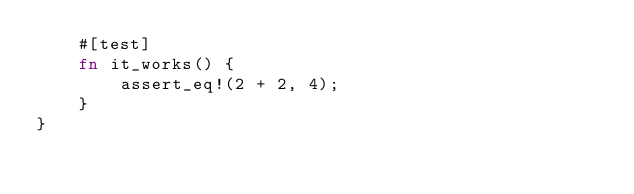<code> <loc_0><loc_0><loc_500><loc_500><_Rust_>    #[test]
    fn it_works() {
        assert_eq!(2 + 2, 4);
    }
}
</code> 